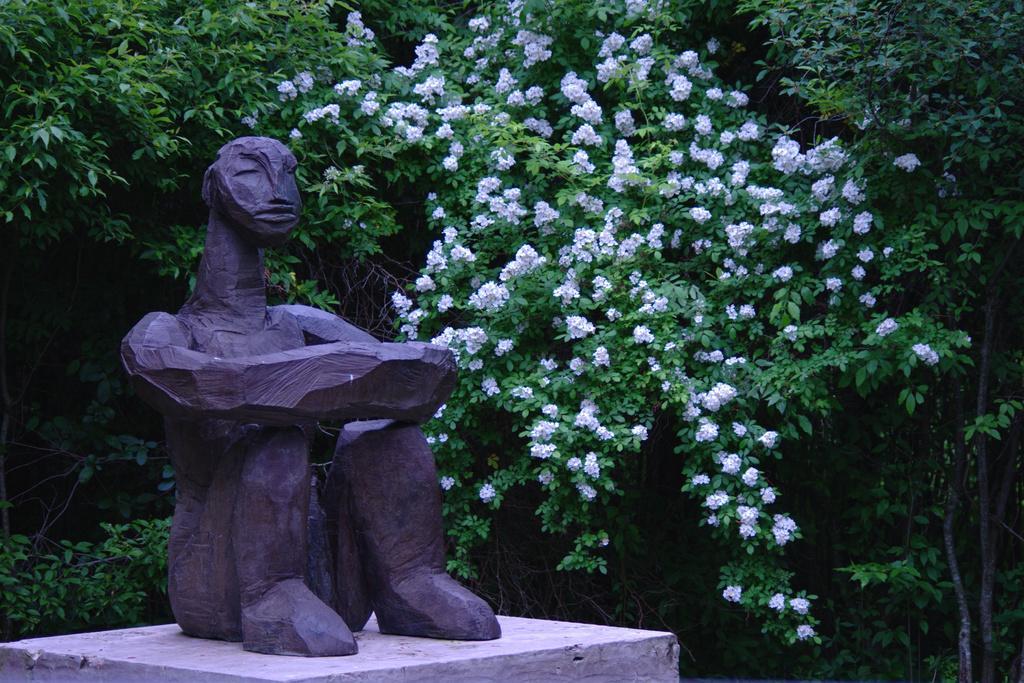How would you summarize this image in a sentence or two? In this picture we can see a statue, behind the statue we can find few flowers and trees. 